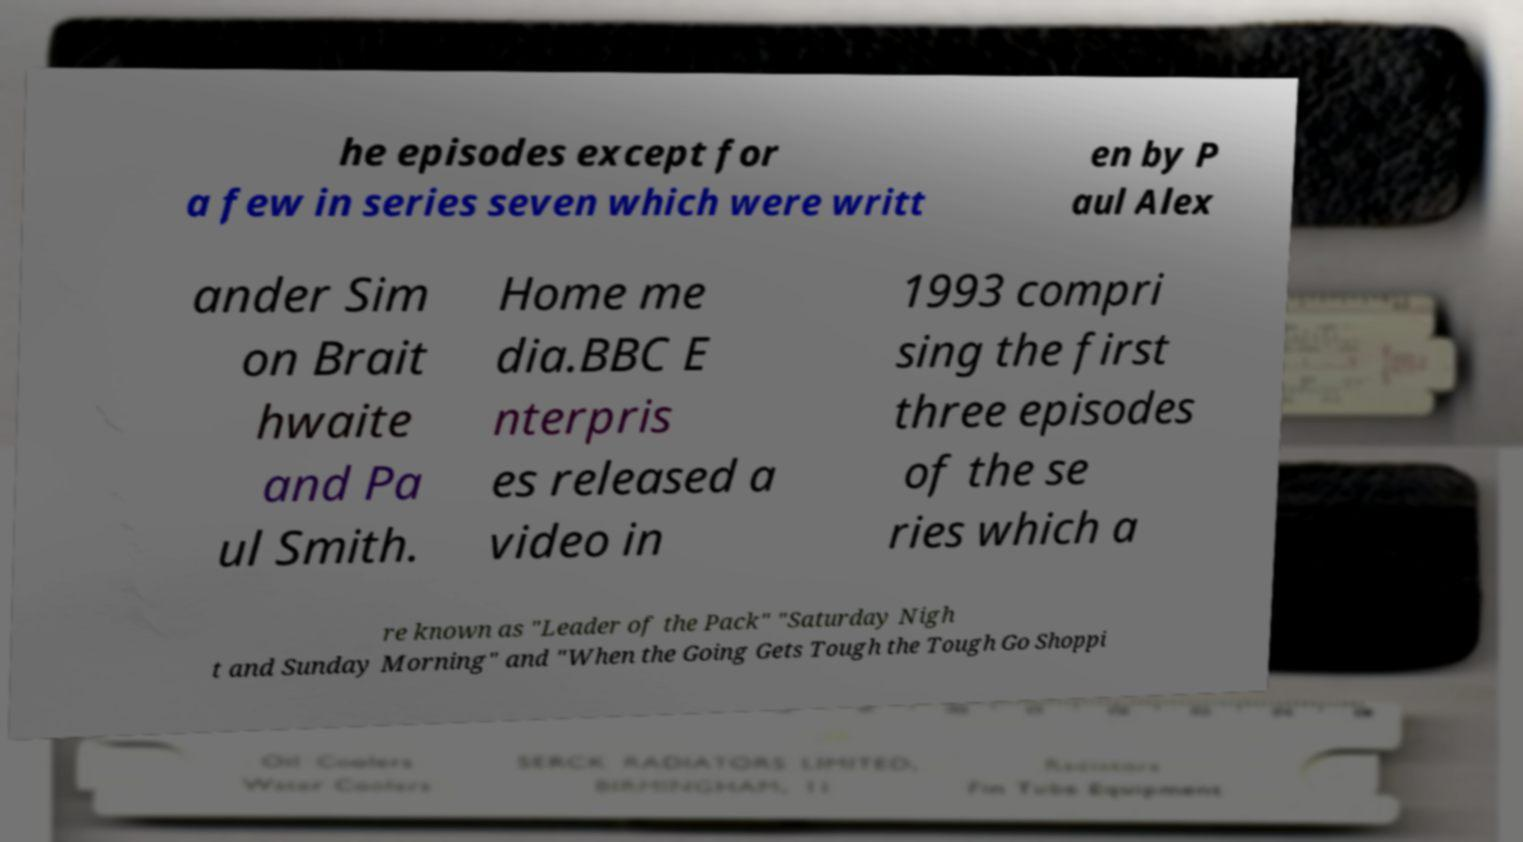For documentation purposes, I need the text within this image transcribed. Could you provide that? he episodes except for a few in series seven which were writt en by P aul Alex ander Sim on Brait hwaite and Pa ul Smith. Home me dia.BBC E nterpris es released a video in 1993 compri sing the first three episodes of the se ries which a re known as "Leader of the Pack" "Saturday Nigh t and Sunday Morning" and "When the Going Gets Tough the Tough Go Shoppi 